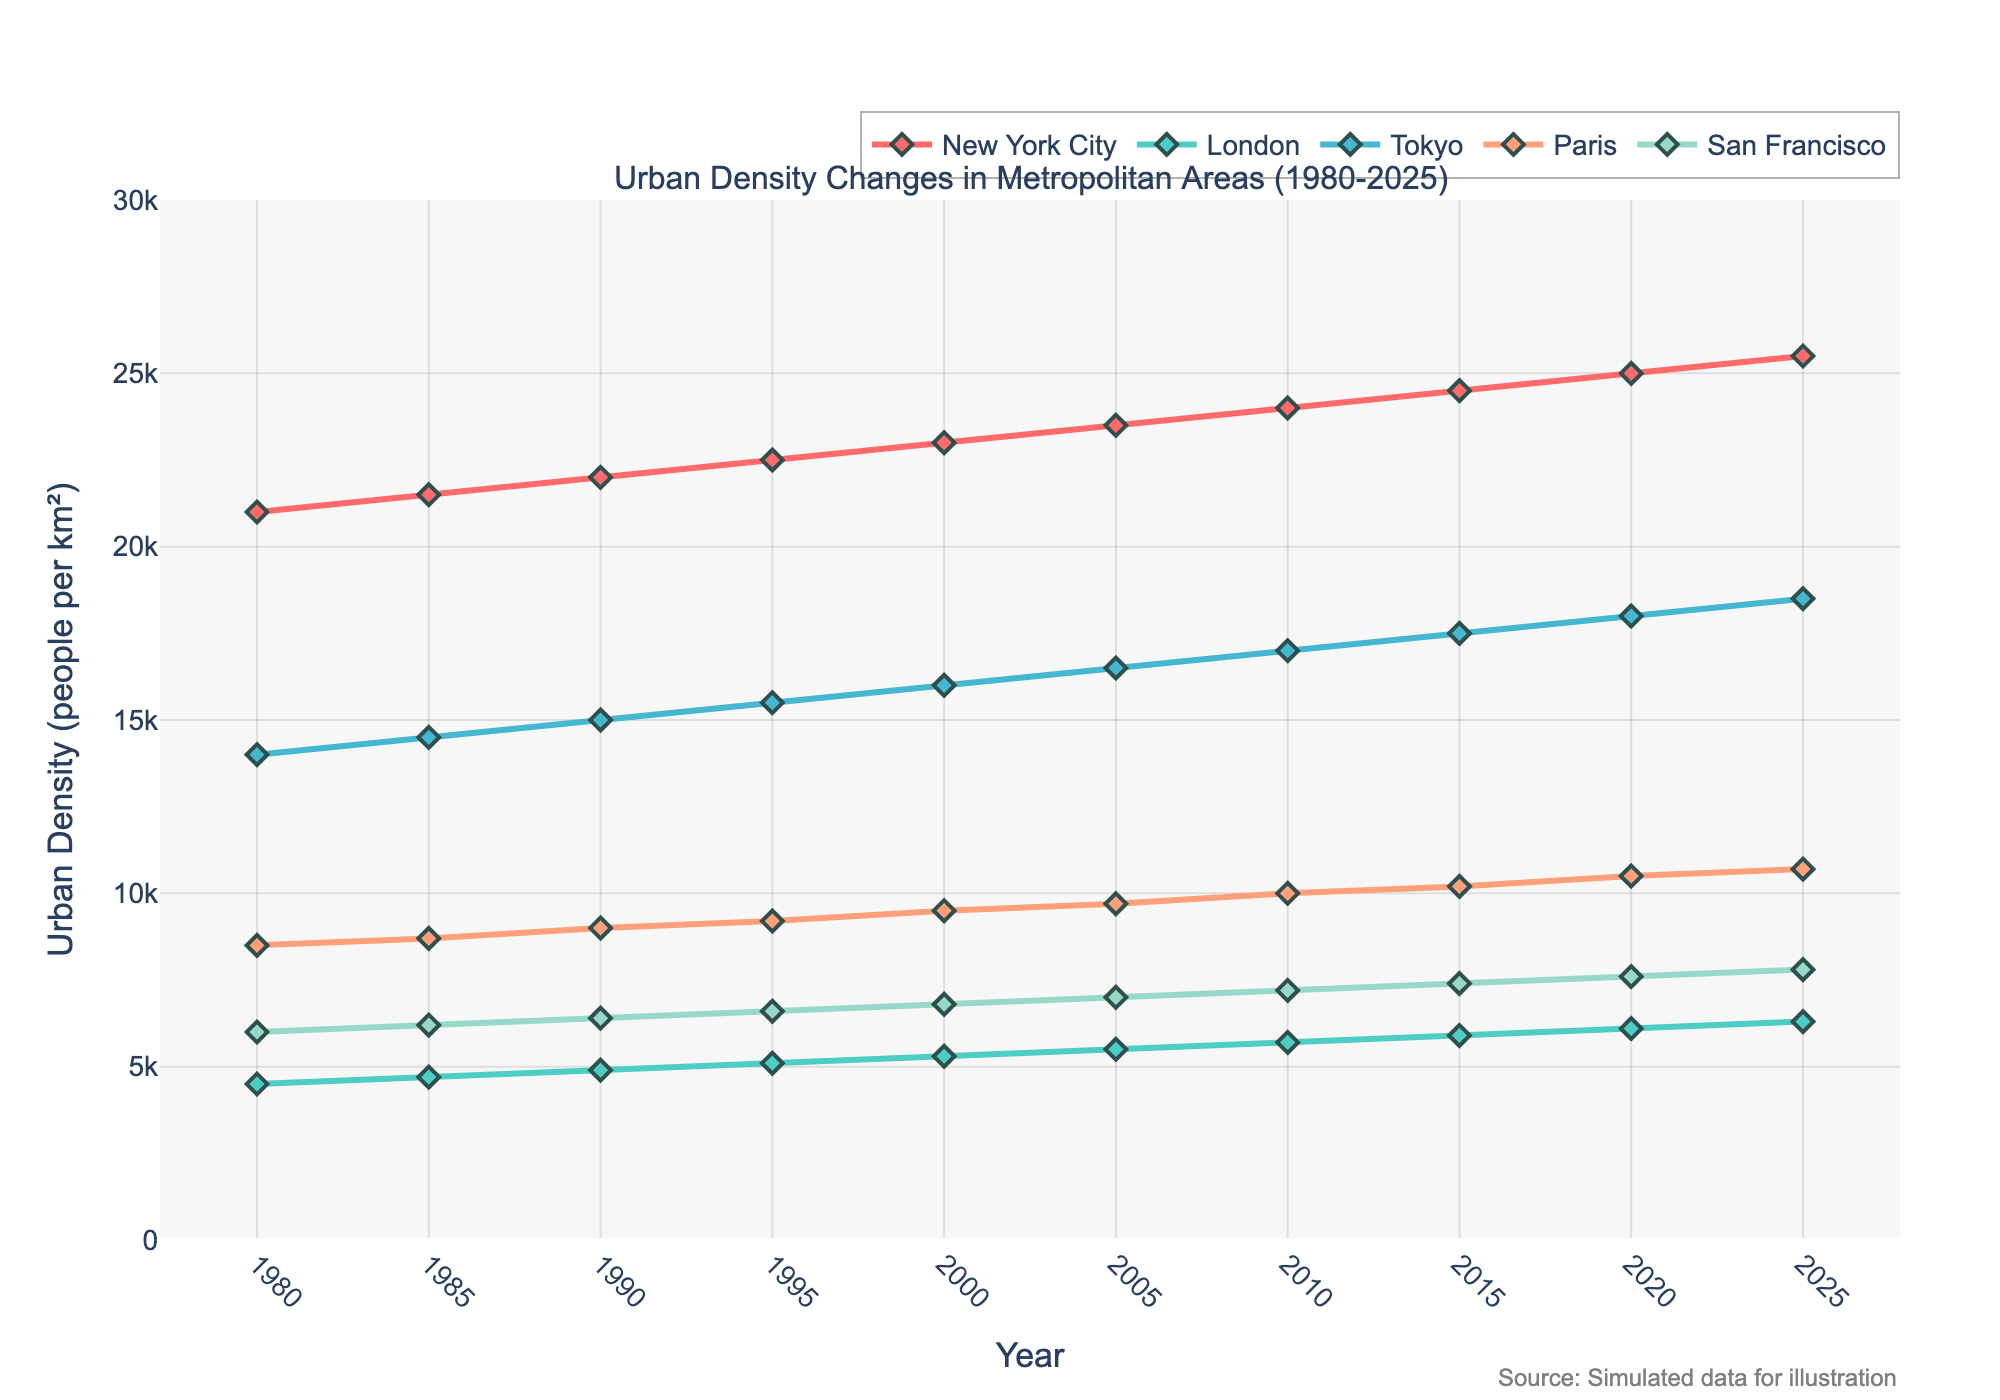What is the urban density of New York City in 2000? Look for the value corresponding to New York City for the year 2000 on the y-axis. The plot shows it as 23,000 people per km².
Answer: 23,000 people per km² Which city had a higher urban density in 1990, Tokyo or Paris? Compare the y-values for Tokyo and Paris in 1990. Tokyo had a density of 15,000 while Paris had 9,000. Hence, Tokyo had a higher density.
Answer: Tokyo How much did the urban density of San Francisco increase from 1980 to 2025? Subtract the 1980 value from the 2025 value for San Francisco: (7,800 - 6,000) = 1,800 people per km².
Answer: 1,800 people per km² Which city had the largest increase in urban density between 1980 and 2025? Calculate the difference for each city (2025 value - 1980 value) and find the maximum: 
New York City: 25,500-21,000 = 4,500
London: 6,300-4,500 = 1,800
Tokyo: 18,500-14,000 = 4,500
Paris: 10,700-8,500 = 2,200
San Francisco: 7,800-6,000 = 1,800
Both New York City and Tokyo had the largest increase of 4,500.
Answer: New York City and Tokyo In what year did London surpass an urban density of 5,500 people per km²? Look for the year when London's density first exceeds 5,500 people per km². This happens in 2005 when London's density is 5,500 and in 2010 it exceeds that, being 5,700.
Answer: 2010 What is the average urban density of Paris from 1980 to 2025? Sum the densities for Paris from 1980 to 2025 and divide by the number of data points (1980, 1985, 1990, 1995, 2000, 2005, 2010, 2015, 2020, 2025): (8,500 + 8,700 + 9,000 + 9,200 + 9,500 + 9,700 + 10,000 + 10,200 + 10,500 + 10,700) and divide by 10:  (94,000 / 10) = 9,400 people per km².
Answer: 9,400 people per km² By how many people per km² did Tokyo's urban density change between 2010 and 2025? Subtract the density in 2010 from the density in 2025 for Tokyo: (18,500 - 17,000) = 1,500 people per km².
Answer: 1,500 people per km² Which city had the lowest urban density in 1980, and what was the density? Compare the densities of all cities for the year 1980. London had the lowest density at 4,500 people per km².
Answer: London, 4,500 people per km² How many cities had an urban density greater than 10,000 people per km² in 2025? Check the values for each city in 2025 and count those greater than 10,000. New York City, Tokyo, and Paris had densities exceeding 10,000.
Answer: Three cities How much higher was the urban density of New York City compared to London in 2020? Subtract London's 2020 value from New York City's 2020 value: (25,000 - 6,100) = 18,900 people per km².
Answer: 18,900 people per km² 